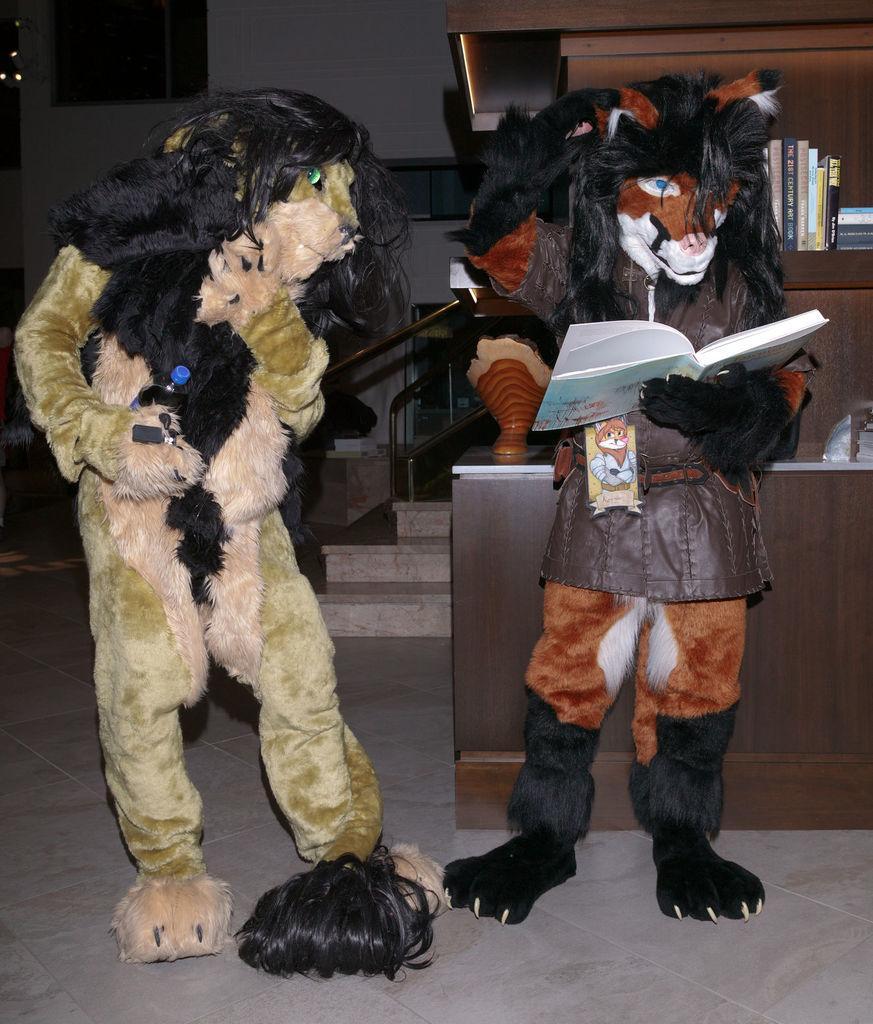Could you give a brief overview of what you see in this image? In this image on the right, there is a toy. It is holding a book. On the left there is a toy, it is holding a bottle. In the background there are books, toys, staircase and wall. 